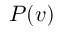Convert formula to latex. <formula><loc_0><loc_0><loc_500><loc_500>P ( v )</formula> 